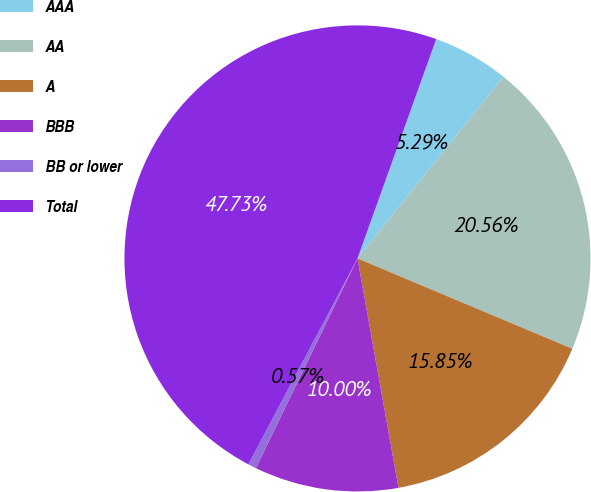Convert chart. <chart><loc_0><loc_0><loc_500><loc_500><pie_chart><fcel>AAA<fcel>AA<fcel>A<fcel>BBB<fcel>BB or lower<fcel>Total<nl><fcel>5.29%<fcel>20.56%<fcel>15.85%<fcel>10.0%<fcel>0.57%<fcel>47.73%<nl></chart> 